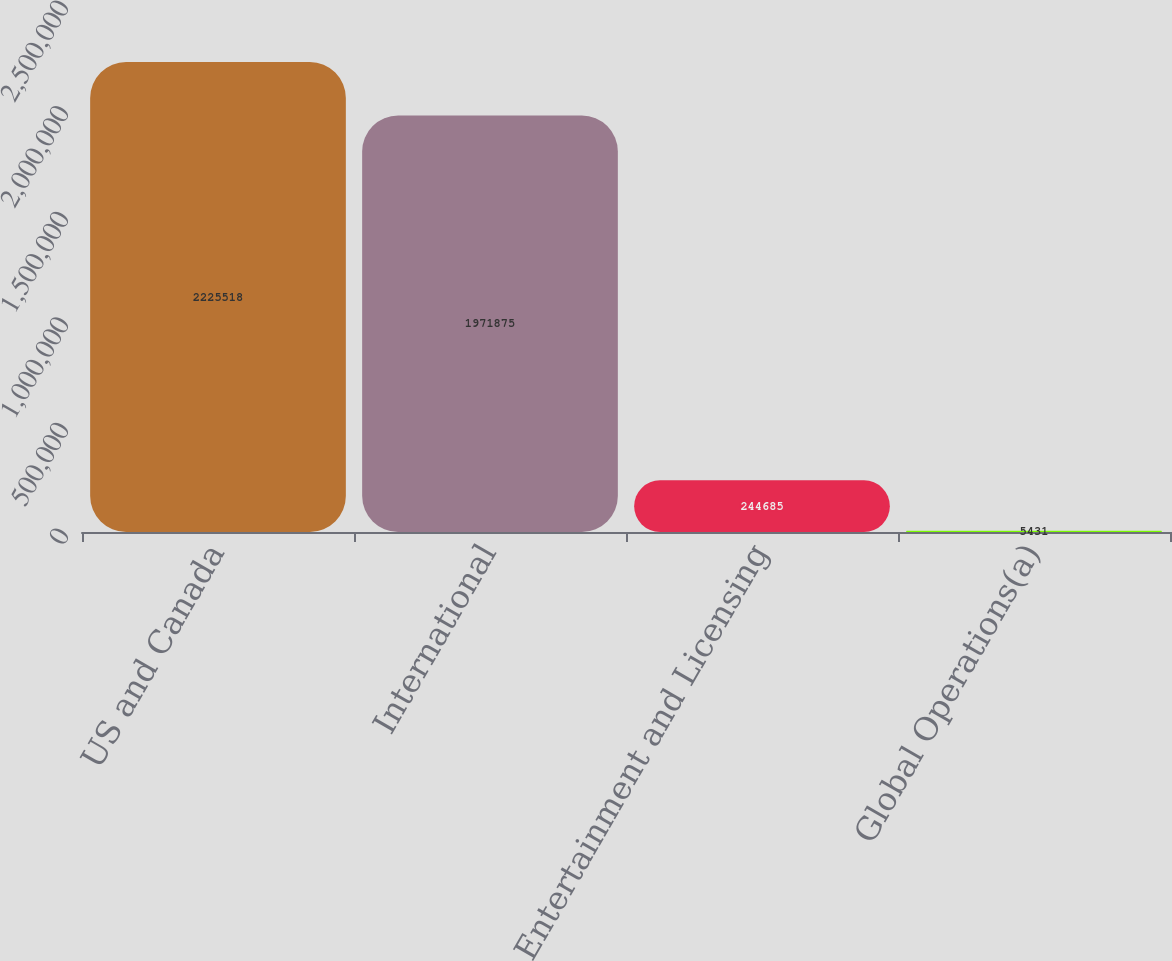<chart> <loc_0><loc_0><loc_500><loc_500><bar_chart><fcel>US and Canada<fcel>International<fcel>Entertainment and Licensing<fcel>Global Operations(a)<nl><fcel>2.22552e+06<fcel>1.97188e+06<fcel>244685<fcel>5431<nl></chart> 